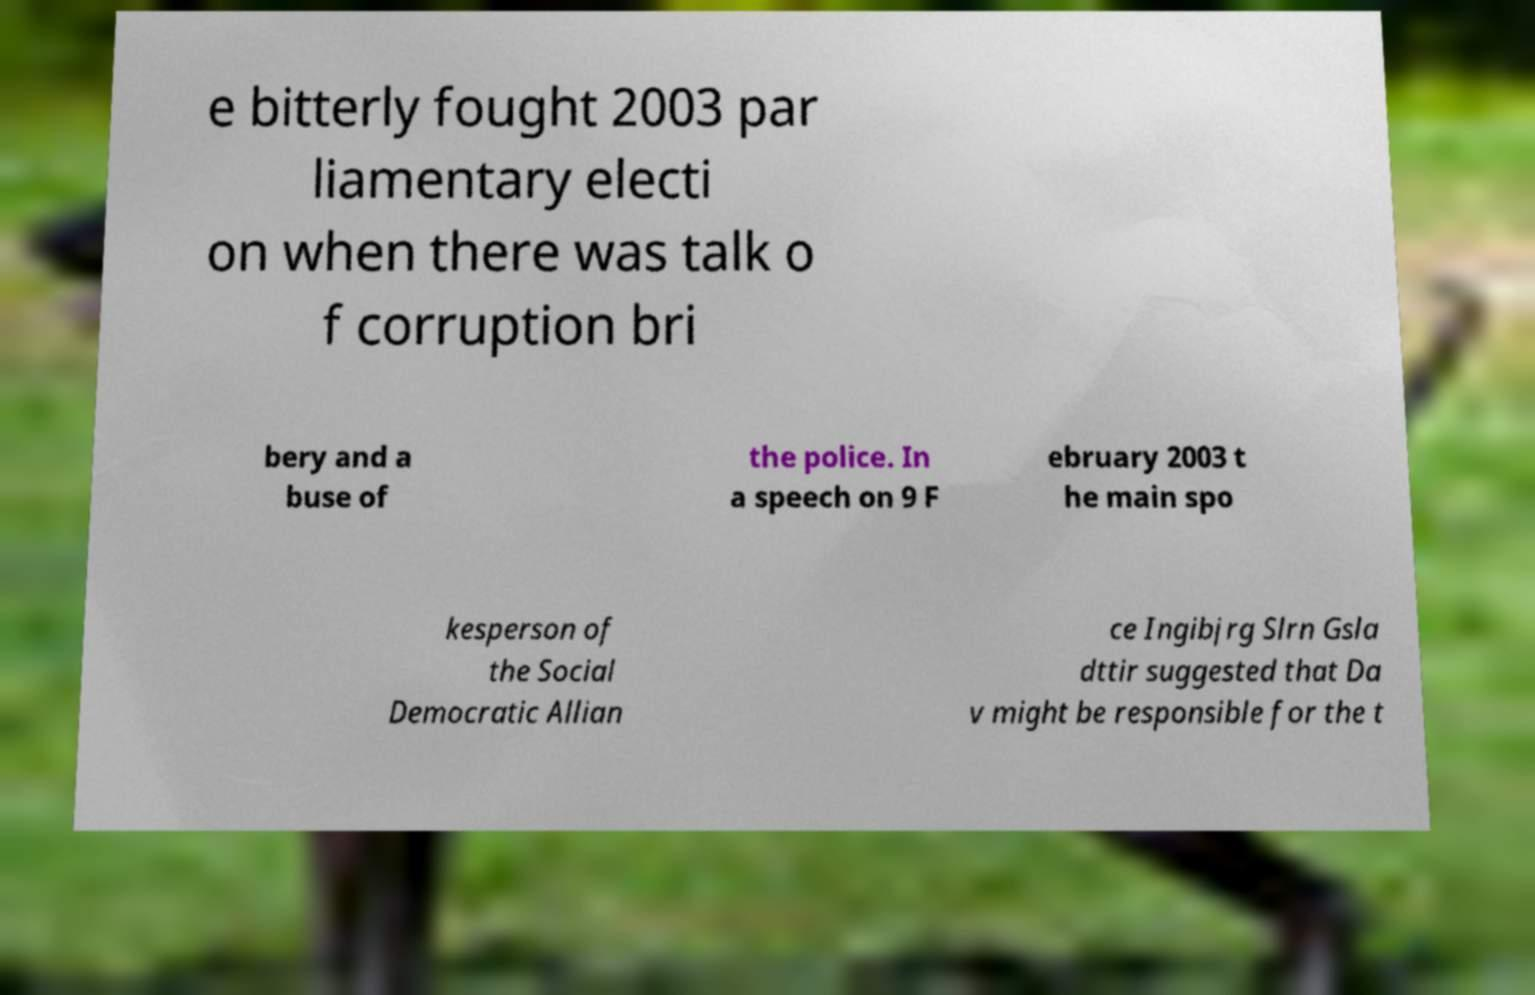I need the written content from this picture converted into text. Can you do that? e bitterly fought 2003 par liamentary electi on when there was talk o f corruption bri bery and a buse of the police. In a speech on 9 F ebruary 2003 t he main spo kesperson of the Social Democratic Allian ce Ingibjrg Slrn Gsla dttir suggested that Da v might be responsible for the t 